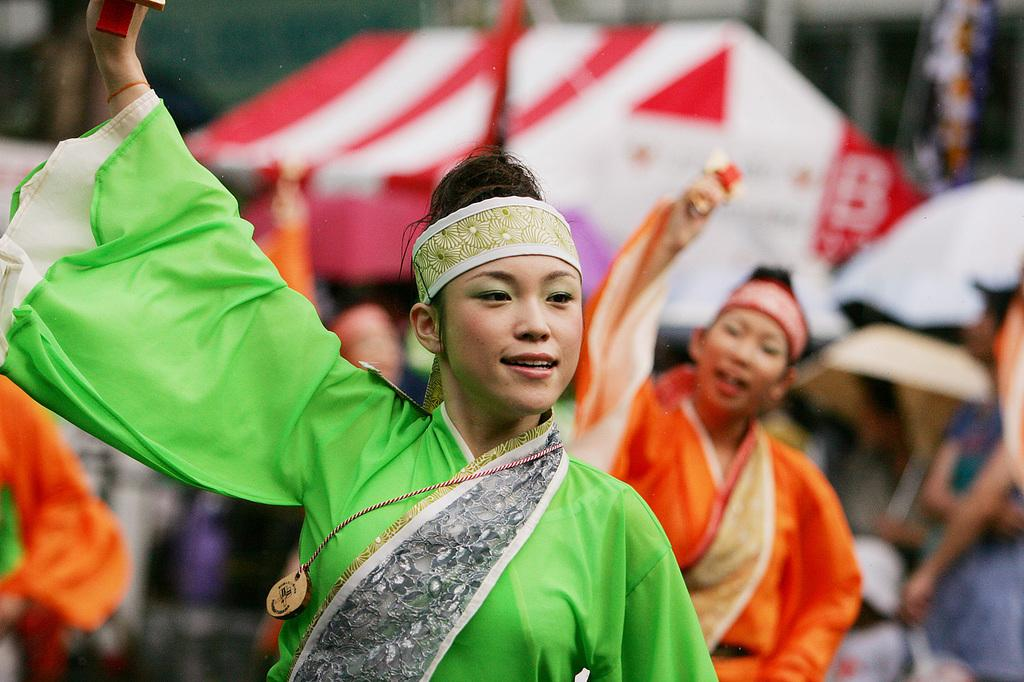What are the people in the image doing? There are persons dancing in the image. What can be seen in the background of the image? There are tents visible in the background of the image. Where are the other persons located in the image? There are persons standing on the right side of the image. What type of railway is visible in the image? There is no railway present in the image. What error can be seen in the image? There is no error visible in the image. 